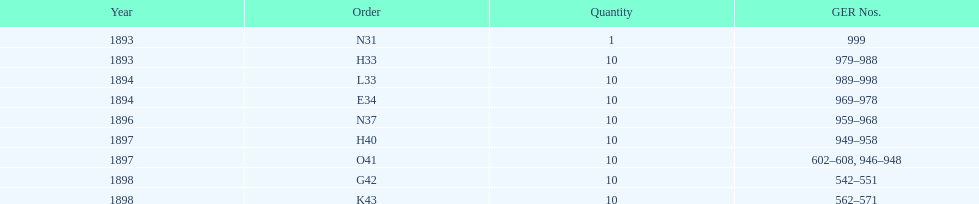Over how many years does the time span extend? 5 years. 